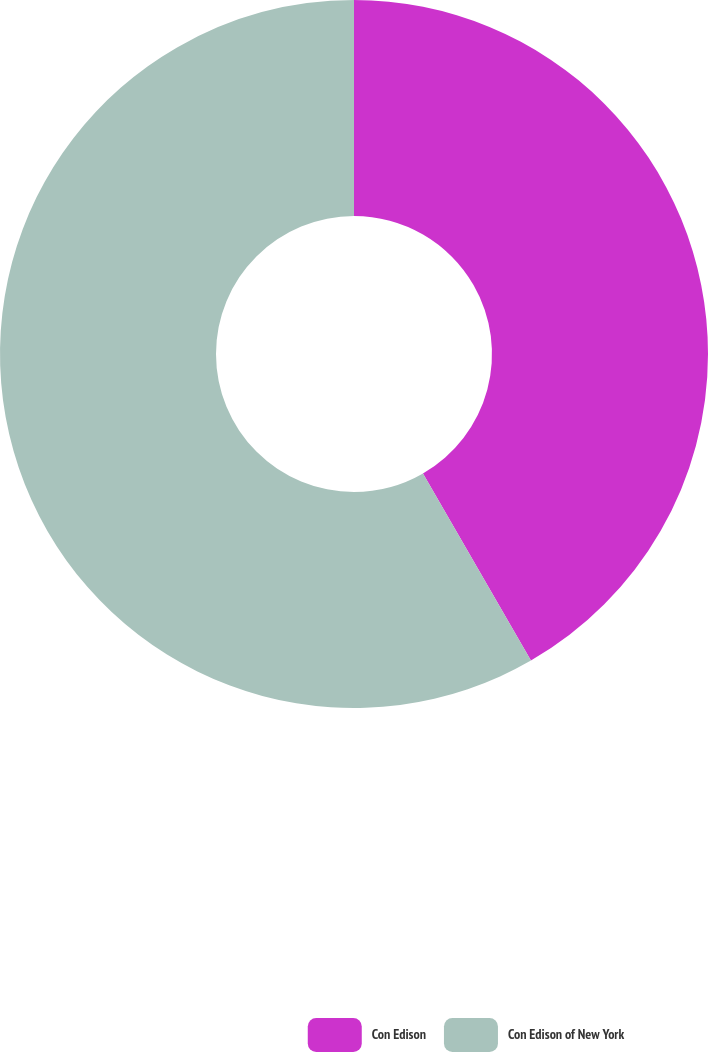Convert chart to OTSL. <chart><loc_0><loc_0><loc_500><loc_500><pie_chart><fcel>Con Edison<fcel>Con Edison of New York<nl><fcel>41.67%<fcel>58.33%<nl></chart> 